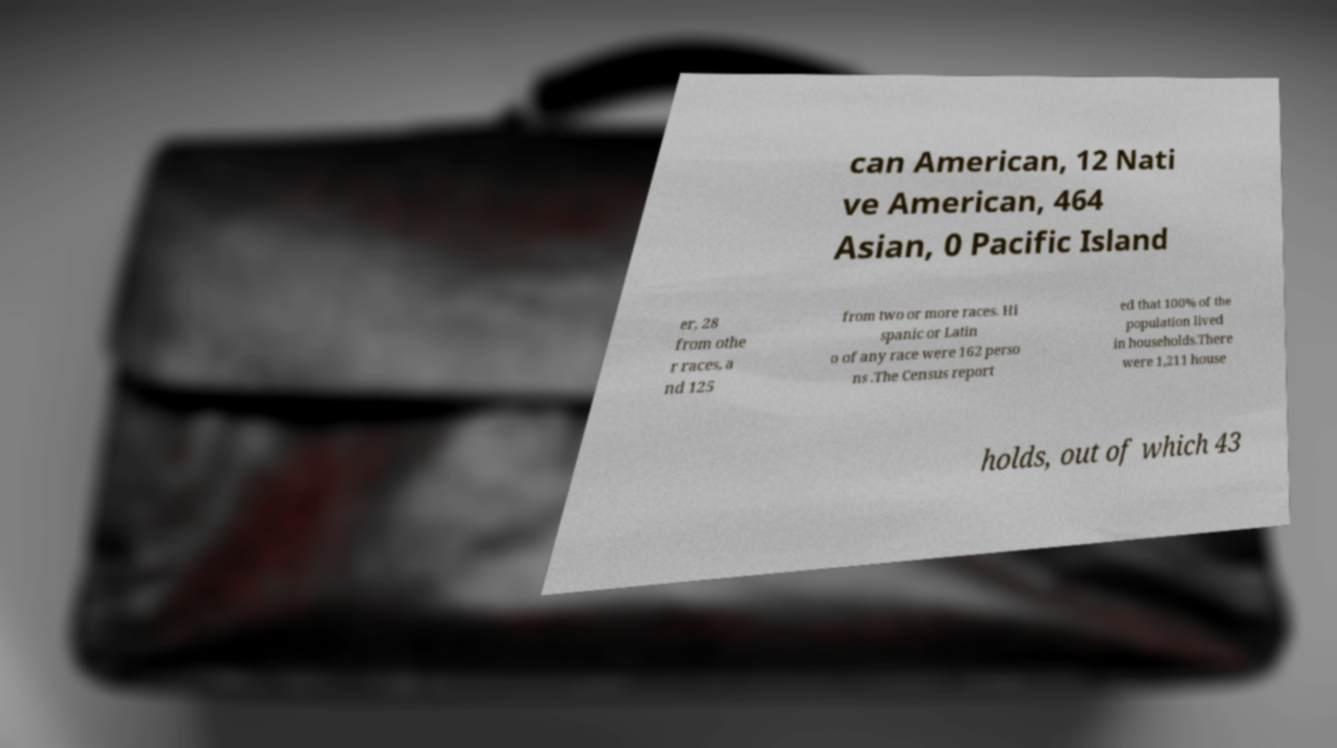There's text embedded in this image that I need extracted. Can you transcribe it verbatim? can American, 12 Nati ve American, 464 Asian, 0 Pacific Island er, 28 from othe r races, a nd 125 from two or more races. Hi spanic or Latin o of any race were 162 perso ns .The Census report ed that 100% of the population lived in households.There were 1,211 house holds, out of which 43 